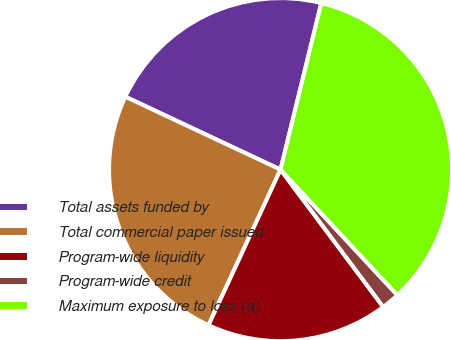Convert chart to OTSL. <chart><loc_0><loc_0><loc_500><loc_500><pie_chart><fcel>Total assets funded by<fcel>Total commercial paper issued<fcel>Program-wide liquidity<fcel>Program-wide credit<fcel>Maximum exposure to loss (a)<nl><fcel>21.83%<fcel>25.09%<fcel>17.12%<fcel>1.71%<fcel>34.25%<nl></chart> 